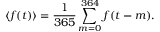Convert formula to latex. <formula><loc_0><loc_0><loc_500><loc_500>\langle f ( t ) \rangle = \frac { 1 } { 3 6 5 } \sum _ { m = 0 } ^ { 3 6 4 } f ( t - m ) .</formula> 